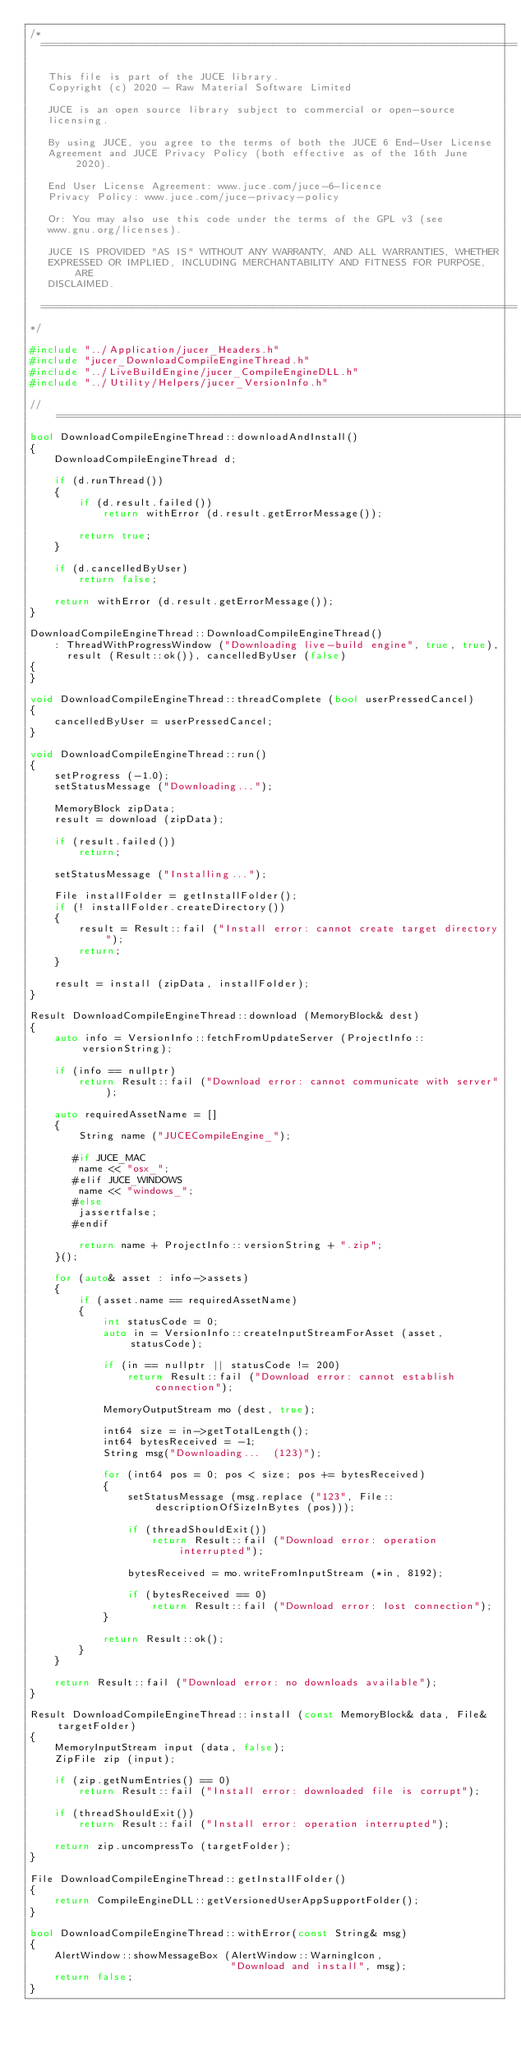Convert code to text. <code><loc_0><loc_0><loc_500><loc_500><_C++_>/*
  ==============================================================================

   This file is part of the JUCE library.
   Copyright (c) 2020 - Raw Material Software Limited

   JUCE is an open source library subject to commercial or open-source
   licensing.

   By using JUCE, you agree to the terms of both the JUCE 6 End-User License
   Agreement and JUCE Privacy Policy (both effective as of the 16th June 2020).

   End User License Agreement: www.juce.com/juce-6-licence
   Privacy Policy: www.juce.com/juce-privacy-policy

   Or: You may also use this code under the terms of the GPL v3 (see
   www.gnu.org/licenses).

   JUCE IS PROVIDED "AS IS" WITHOUT ANY WARRANTY, AND ALL WARRANTIES, WHETHER
   EXPRESSED OR IMPLIED, INCLUDING MERCHANTABILITY AND FITNESS FOR PURPOSE, ARE
   DISCLAIMED.

  ==============================================================================
*/

#include "../Application/jucer_Headers.h"
#include "jucer_DownloadCompileEngineThread.h"
#include "../LiveBuildEngine/jucer_CompileEngineDLL.h"
#include "../Utility/Helpers/jucer_VersionInfo.h"

//==============================================================================
bool DownloadCompileEngineThread::downloadAndInstall()
{
    DownloadCompileEngineThread d;

    if (d.runThread())
    {
        if (d.result.failed())
            return withError (d.result.getErrorMessage());

        return true;
    }

    if (d.cancelledByUser)
        return false;

    return withError (d.result.getErrorMessage());
}

DownloadCompileEngineThread::DownloadCompileEngineThread()
    : ThreadWithProgressWindow ("Downloading live-build engine", true, true),
      result (Result::ok()), cancelledByUser (false)
{
}

void DownloadCompileEngineThread::threadComplete (bool userPressedCancel)
{
    cancelledByUser = userPressedCancel;
}

void DownloadCompileEngineThread::run()
{
    setProgress (-1.0);
    setStatusMessage ("Downloading...");

    MemoryBlock zipData;
    result = download (zipData);

    if (result.failed())
        return;

    setStatusMessage ("Installing...");

    File installFolder = getInstallFolder();
    if (! installFolder.createDirectory())
    {
        result = Result::fail ("Install error: cannot create target directory");
        return;
    }

    result = install (zipData, installFolder);
}

Result DownloadCompileEngineThread::download (MemoryBlock& dest)
{
    auto info = VersionInfo::fetchFromUpdateServer (ProjectInfo::versionString);

    if (info == nullptr)
        return Result::fail ("Download error: cannot communicate with server");

    auto requiredAssetName = []
    {
        String name ("JUCECompileEngine_");

       #if JUCE_MAC
        name << "osx_";
       #elif JUCE_WINDOWS
        name << "windows_";
       #else
        jassertfalse;
       #endif

        return name + ProjectInfo::versionString + ".zip";
    }();

    for (auto& asset : info->assets)
    {
        if (asset.name == requiredAssetName)
        {
            int statusCode = 0;
            auto in = VersionInfo::createInputStreamForAsset (asset, statusCode);

            if (in == nullptr || statusCode != 200)
                return Result::fail ("Download error: cannot establish connection");

            MemoryOutputStream mo (dest, true);

            int64 size = in->getTotalLength();
            int64 bytesReceived = -1;
            String msg("Downloading...  (123)");

            for (int64 pos = 0; pos < size; pos += bytesReceived)
            {
                setStatusMessage (msg.replace ("123", File::descriptionOfSizeInBytes (pos)));

                if (threadShouldExit())
                    return Result::fail ("Download error: operation interrupted");

                bytesReceived = mo.writeFromInputStream (*in, 8192);

                if (bytesReceived == 0)
                    return Result::fail ("Download error: lost connection");
            }

            return Result::ok();
        }
    }

    return Result::fail ("Download error: no downloads available");
}

Result DownloadCompileEngineThread::install (const MemoryBlock& data, File& targetFolder)
{
    MemoryInputStream input (data, false);
    ZipFile zip (input);

    if (zip.getNumEntries() == 0)
        return Result::fail ("Install error: downloaded file is corrupt");

    if (threadShouldExit())
        return Result::fail ("Install error: operation interrupted");

    return zip.uncompressTo (targetFolder);
}

File DownloadCompileEngineThread::getInstallFolder()
{
    return CompileEngineDLL::getVersionedUserAppSupportFolder();
}

bool DownloadCompileEngineThread::withError(const String& msg)
{
    AlertWindow::showMessageBox (AlertWindow::WarningIcon,
                                 "Download and install", msg);
    return false;
}
</code> 